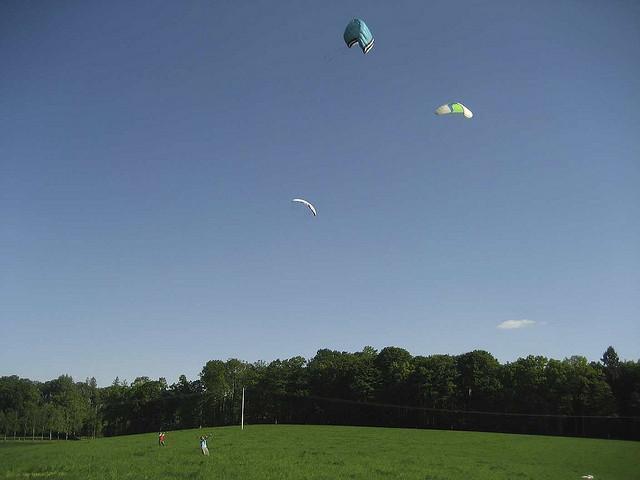How many kites are in the sky?
Give a very brief answer. 3. How many kites are flying?
Give a very brief answer. 3. 